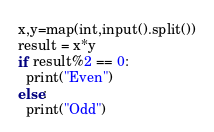Convert code to text. <code><loc_0><loc_0><loc_500><loc_500><_Python_>x,y=map(int,input().split())
result = x*y
if result%2 == 0:
  print("Even")
else:
  print("Odd")</code> 